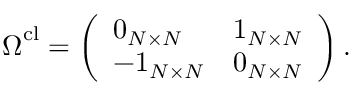<formula> <loc_0><loc_0><loc_500><loc_500>\Omega ^ { c l } = \left ( \begin{array} { l l } { 0 _ { N \times N } } & { 1 _ { N \times N } } \\ { - 1 _ { N \times N } } & { 0 _ { N \times N } } \end{array} \right ) .</formula> 